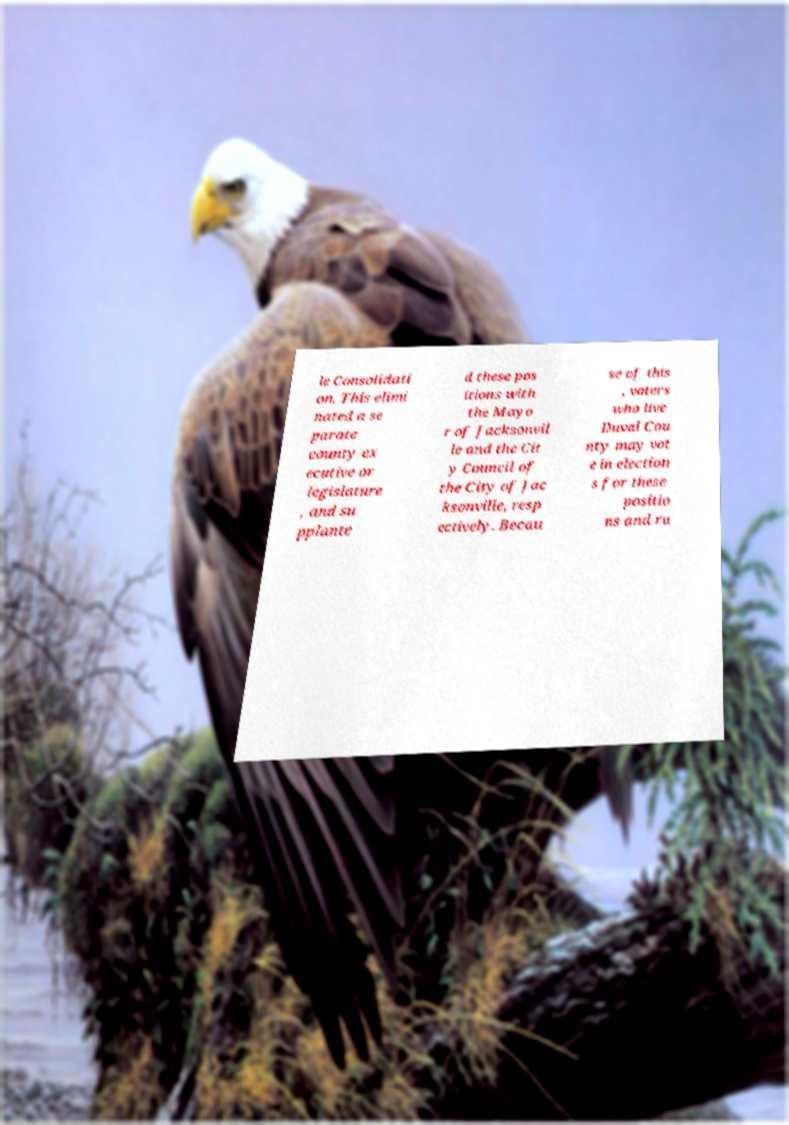Please read and relay the text visible in this image. What does it say? le Consolidati on. This elimi nated a se parate county ex ecutive or legislature , and su pplante d these pos itions with the Mayo r of Jacksonvil le and the Cit y Council of the City of Jac ksonville, resp ectively. Becau se of this , voters who live Duval Cou nty may vot e in election s for these positio ns and ru 